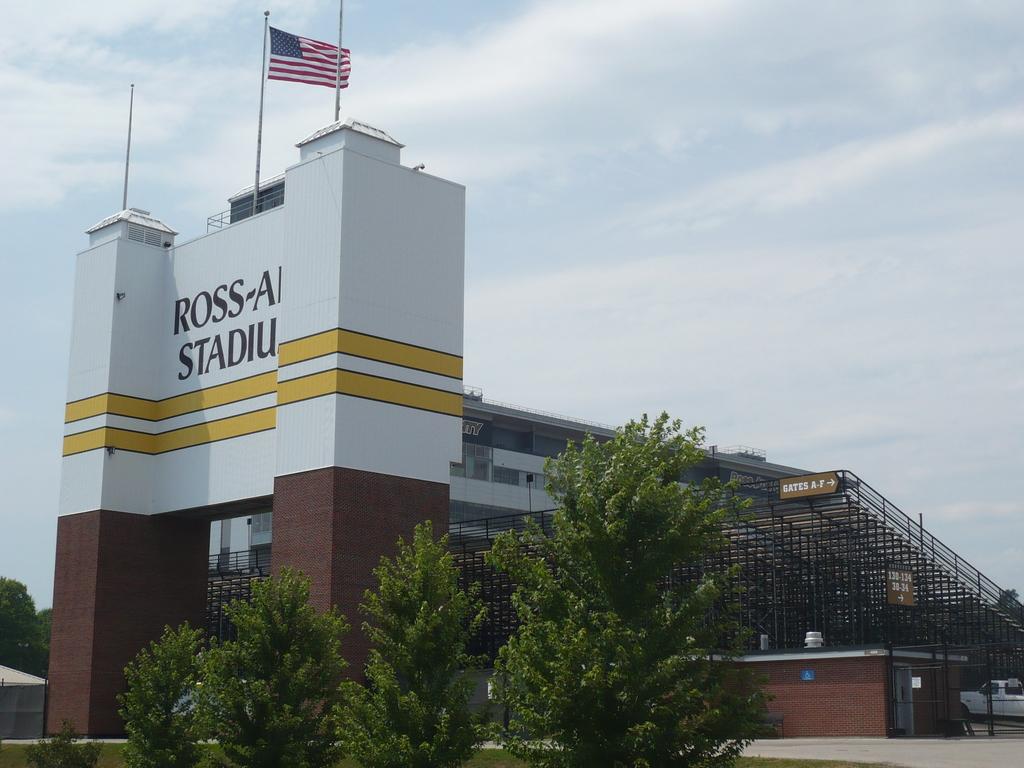Is the first name "ross" on the entrance?
Provide a succinct answer. Yes. Is there an american flag in the image?
Provide a succinct answer. Answering does not require reading text in the image. 